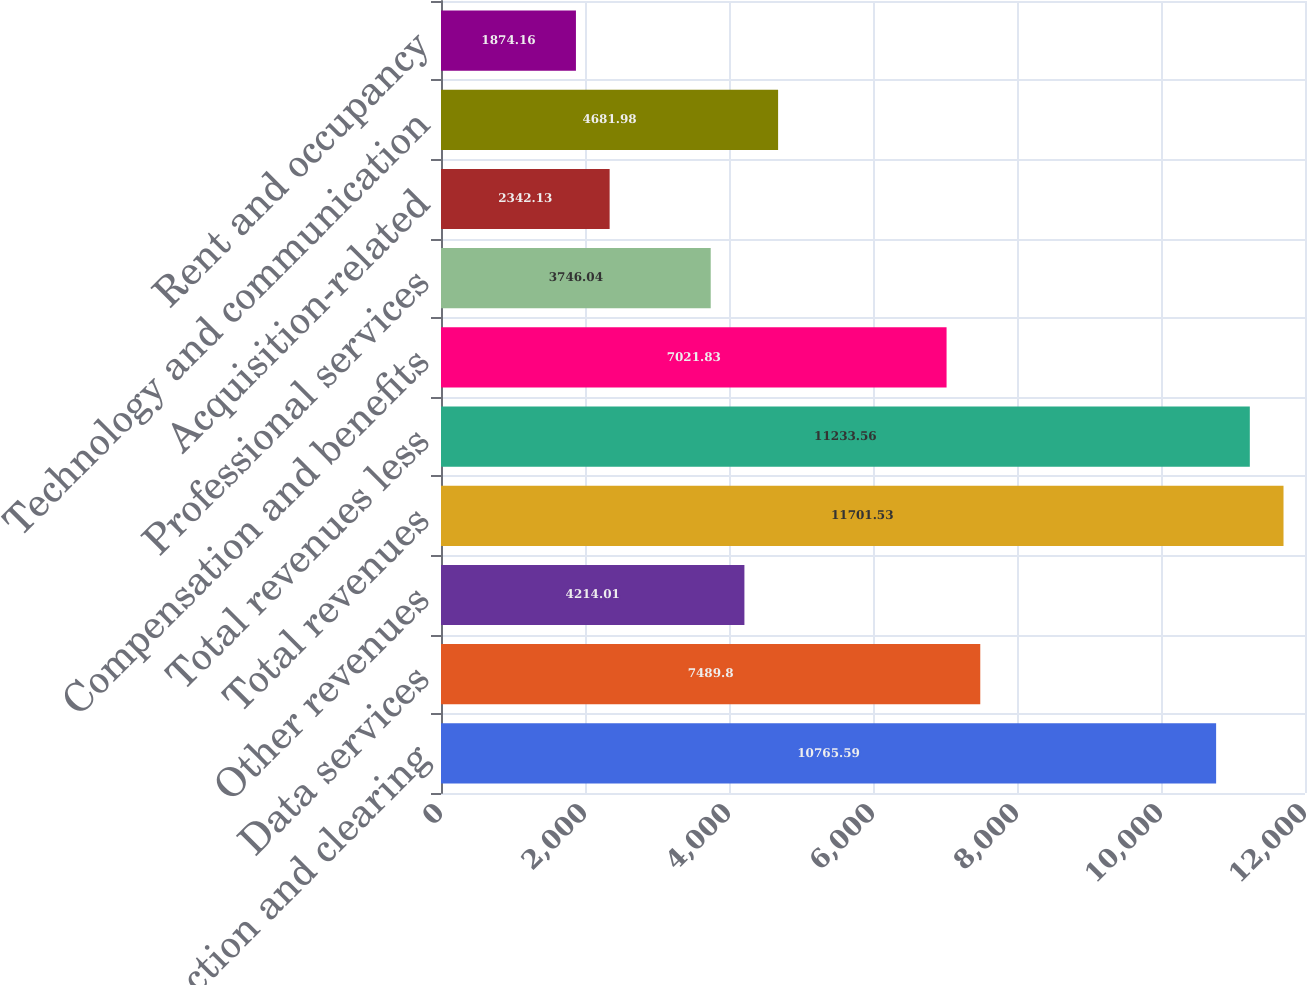<chart> <loc_0><loc_0><loc_500><loc_500><bar_chart><fcel>Transaction and clearing<fcel>Data services<fcel>Other revenues<fcel>Total revenues<fcel>Total revenues less<fcel>Compensation and benefits<fcel>Professional services<fcel>Acquisition-related<fcel>Technology and communication<fcel>Rent and occupancy<nl><fcel>10765.6<fcel>7489.8<fcel>4214.01<fcel>11701.5<fcel>11233.6<fcel>7021.83<fcel>3746.04<fcel>2342.13<fcel>4681.98<fcel>1874.16<nl></chart> 